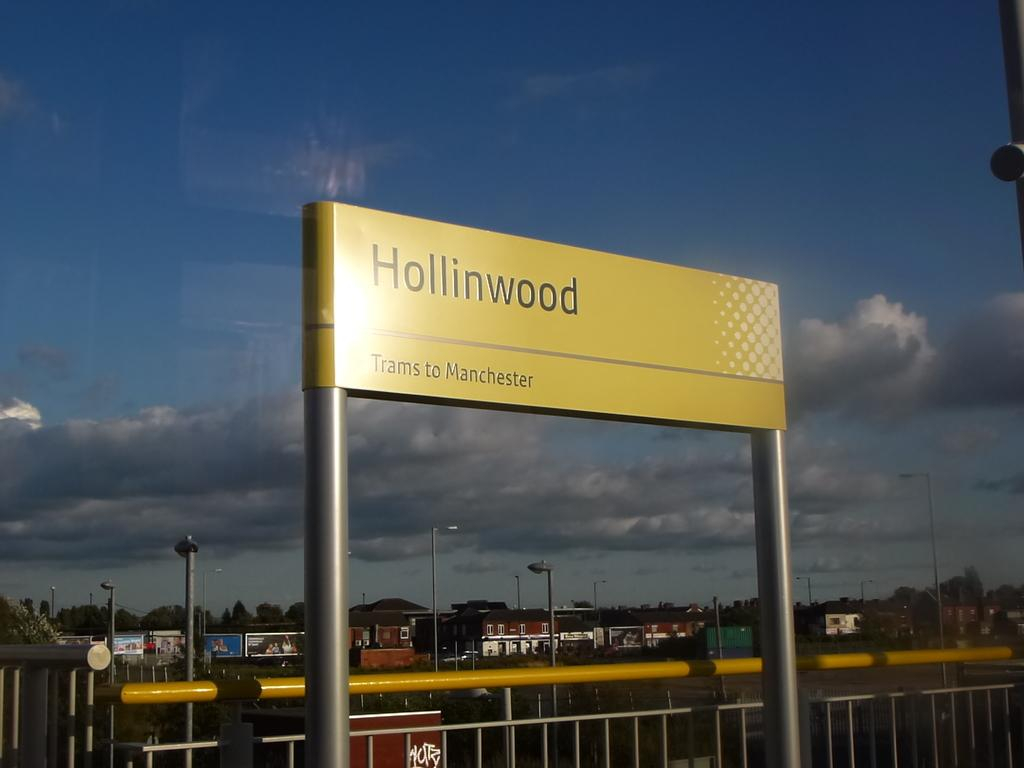<image>
Relay a brief, clear account of the picture shown. A large yellow sign above a railing says Hollinwood. 